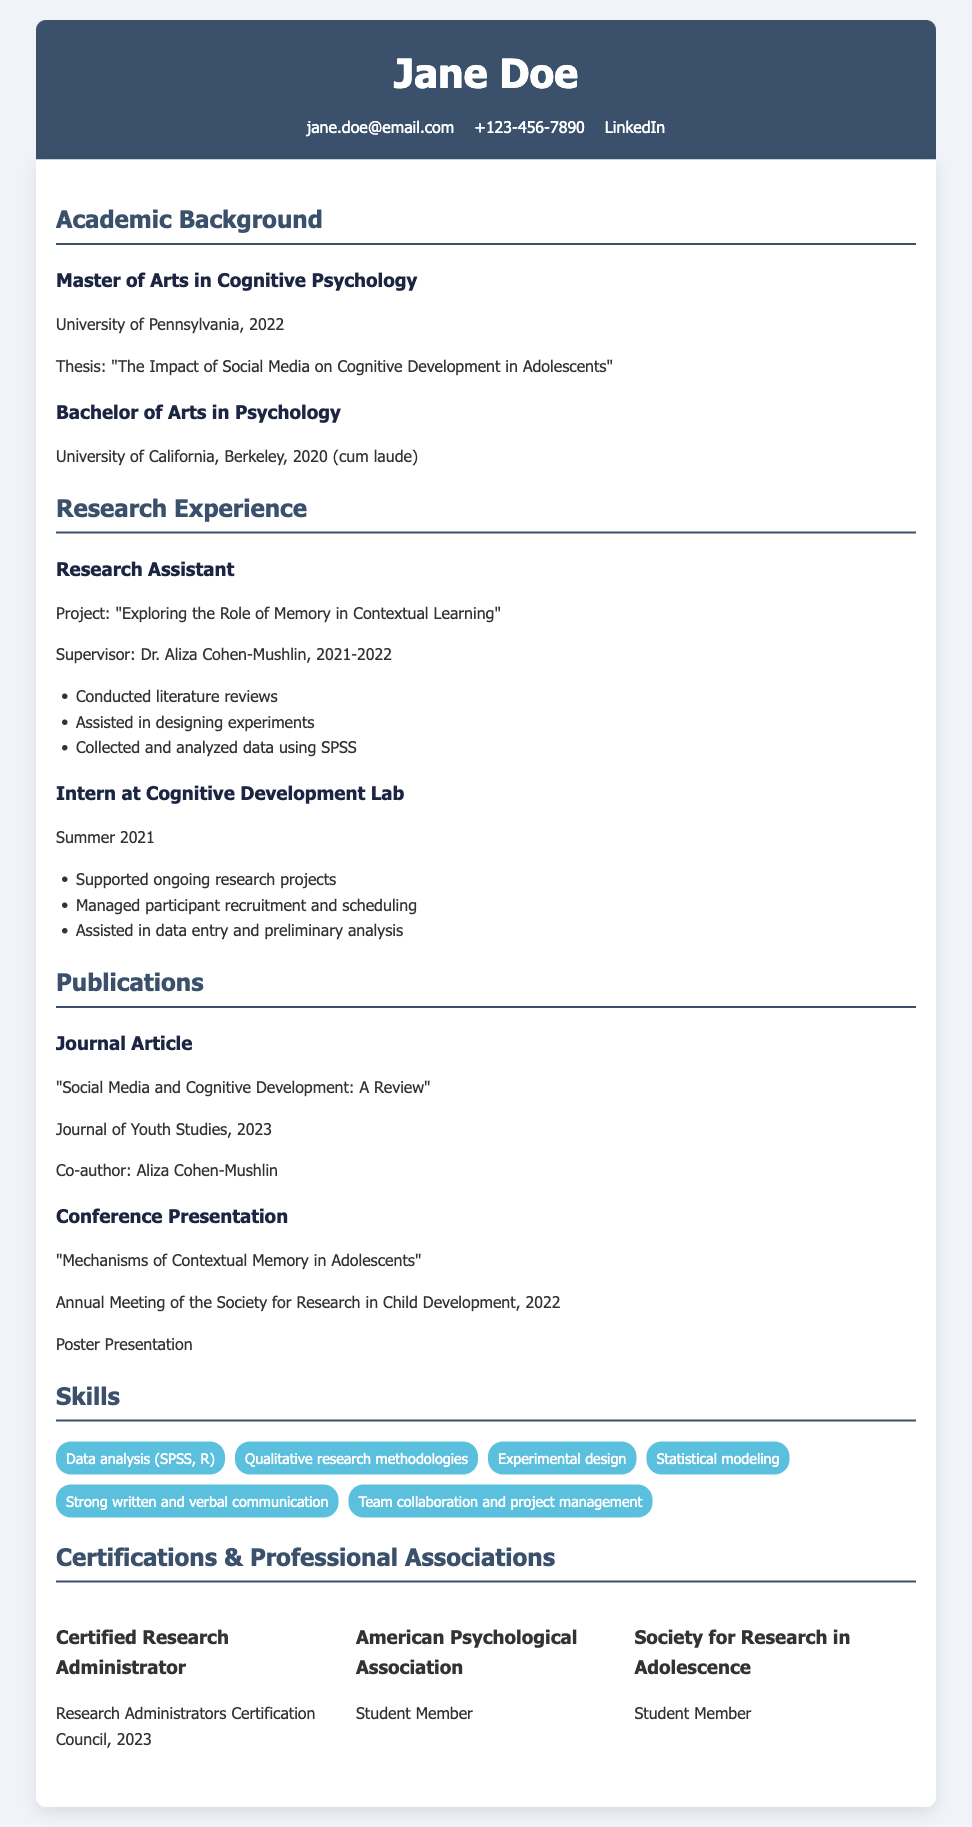What is the title of Jane Doe's thesis? The thesis title is mentioned under the academic background section, specifically for her Master of Arts degree.
Answer: The Impact of Social Media on Cognitive Development in Adolescents Who supervised Jane Doe during her research assistantship? The supervisor’s name is listed in the research experience section.
Answer: Dr. Aliza Cohen-Mushlin What year did Jane Doe graduate with her Bachelor of Arts degree? The graduation year is mentioned in the academic background section for her Bachelor’s degree.
Answer: 2020 What is one of the skills listed in Jane Doe's Curriculum Vitae? The skills are outlined under the skills section, and several specific skills are mentioned.
Answer: Data analysis (SPSS, R) How many publications does Jane Doe have listed? The number of publications can be counted from the publications section of the document.
Answer: 2 What organization is Jane Doe a student member of? The associations are listed in the certifications and professional associations section; one specific organization is highlighted.
Answer: American Psychological Association What was Jane Doe's role in the Cognitive Development Lab? The role in the lab is mentioned in the research experience section related to her internship.
Answer: Intern In what year was Jane Doe certified as a Research Administrator? The certification year is clearly stated in the certifications section.
Answer: 2023 